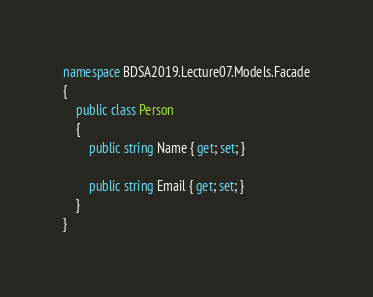Convert code to text. <code><loc_0><loc_0><loc_500><loc_500><_C#_>namespace BDSA2019.Lecture07.Models.Facade
{
    public class Person
    {
        public string Name { get; set; }

        public string Email { get; set; }
    }
}
</code> 